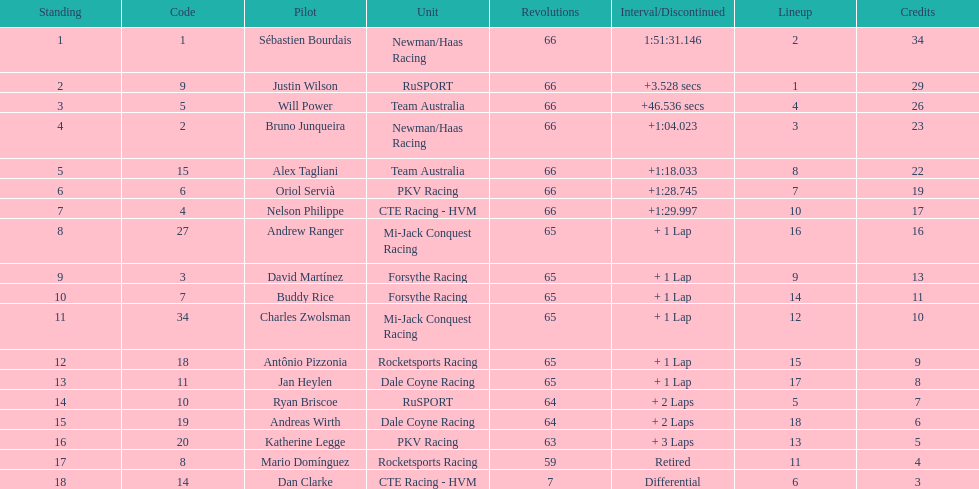How many drivers did not make more than 60 laps? 2. 